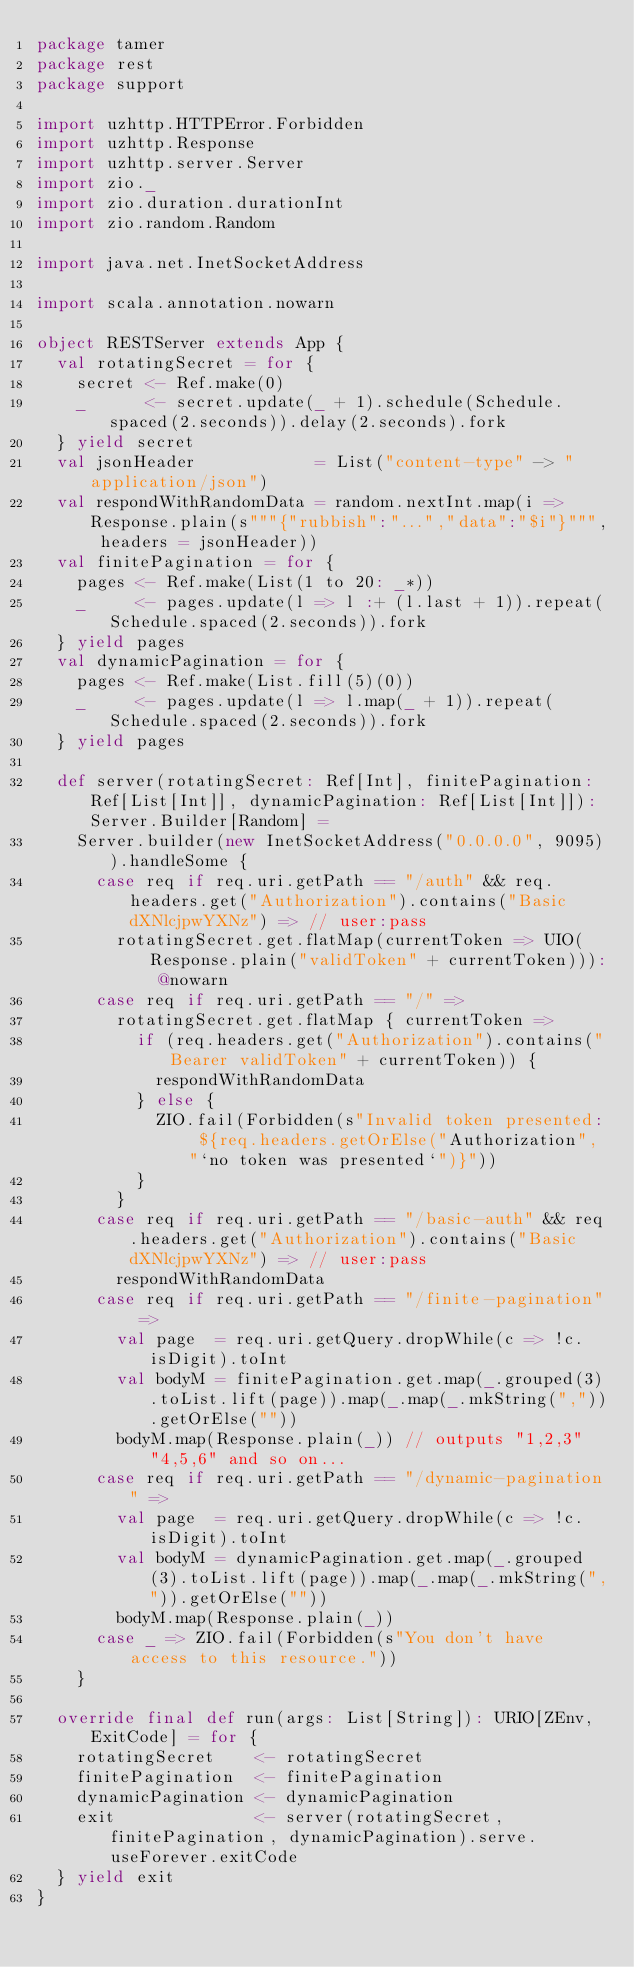<code> <loc_0><loc_0><loc_500><loc_500><_Scala_>package tamer
package rest
package support

import uzhttp.HTTPError.Forbidden
import uzhttp.Response
import uzhttp.server.Server
import zio._
import zio.duration.durationInt
import zio.random.Random

import java.net.InetSocketAddress

import scala.annotation.nowarn

object RESTServer extends App {
  val rotatingSecret = for {
    secret <- Ref.make(0)
    _      <- secret.update(_ + 1).schedule(Schedule.spaced(2.seconds)).delay(2.seconds).fork
  } yield secret
  val jsonHeader            = List("content-type" -> "application/json")
  val respondWithRandomData = random.nextInt.map(i => Response.plain(s"""{"rubbish":"...","data":"$i"}""", headers = jsonHeader))
  val finitePagination = for {
    pages <- Ref.make(List(1 to 20: _*))
    _     <- pages.update(l => l :+ (l.last + 1)).repeat(Schedule.spaced(2.seconds)).fork
  } yield pages
  val dynamicPagination = for {
    pages <- Ref.make(List.fill(5)(0))
    _     <- pages.update(l => l.map(_ + 1)).repeat(Schedule.spaced(2.seconds)).fork
  } yield pages

  def server(rotatingSecret: Ref[Int], finitePagination: Ref[List[Int]], dynamicPagination: Ref[List[Int]]): Server.Builder[Random] =
    Server.builder(new InetSocketAddress("0.0.0.0", 9095)).handleSome {
      case req if req.uri.getPath == "/auth" && req.headers.get("Authorization").contains("Basic dXNlcjpwYXNz") => // user:pass
        rotatingSecret.get.flatMap(currentToken => UIO(Response.plain("validToken" + currentToken))): @nowarn
      case req if req.uri.getPath == "/" =>
        rotatingSecret.get.flatMap { currentToken =>
          if (req.headers.get("Authorization").contains("Bearer validToken" + currentToken)) {
            respondWithRandomData
          } else {
            ZIO.fail(Forbidden(s"Invalid token presented: ${req.headers.getOrElse("Authorization", "`no token was presented`")}"))
          }
        }
      case req if req.uri.getPath == "/basic-auth" && req.headers.get("Authorization").contains("Basic dXNlcjpwYXNz") => // user:pass
        respondWithRandomData
      case req if req.uri.getPath == "/finite-pagination" =>
        val page  = req.uri.getQuery.dropWhile(c => !c.isDigit).toInt
        val bodyM = finitePagination.get.map(_.grouped(3).toList.lift(page)).map(_.map(_.mkString(",")).getOrElse(""))
        bodyM.map(Response.plain(_)) // outputs "1,2,3" "4,5,6" and so on...
      case req if req.uri.getPath == "/dynamic-pagination" =>
        val page  = req.uri.getQuery.dropWhile(c => !c.isDigit).toInt
        val bodyM = dynamicPagination.get.map(_.grouped(3).toList.lift(page)).map(_.map(_.mkString(",")).getOrElse(""))
        bodyM.map(Response.plain(_))
      case _ => ZIO.fail(Forbidden(s"You don't have access to this resource."))
    }

  override final def run(args: List[String]): URIO[ZEnv, ExitCode] = for {
    rotatingSecret    <- rotatingSecret
    finitePagination  <- finitePagination
    dynamicPagination <- dynamicPagination
    exit              <- server(rotatingSecret, finitePagination, dynamicPagination).serve.useForever.exitCode
  } yield exit
}
</code> 